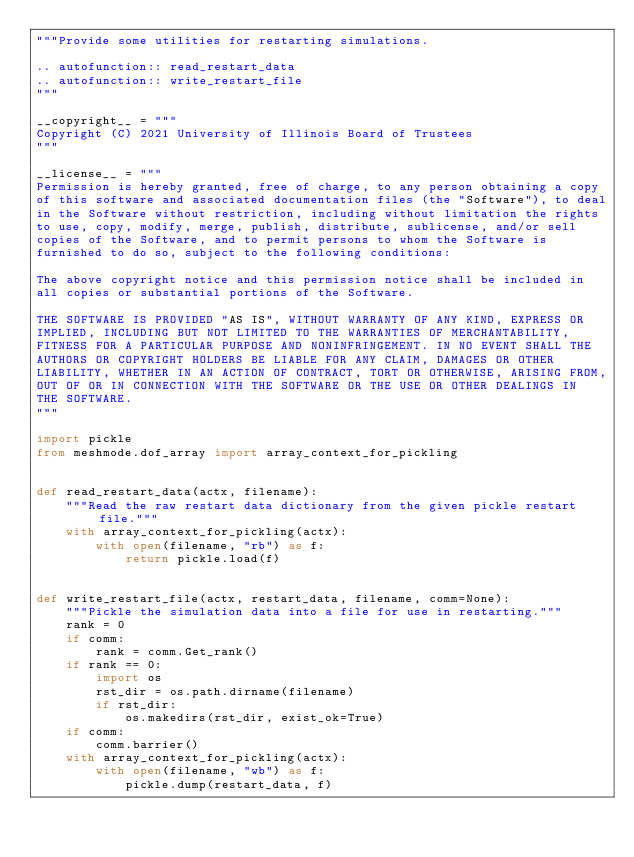<code> <loc_0><loc_0><loc_500><loc_500><_Python_>"""Provide some utilities for restarting simulations.

.. autofunction:: read_restart_data
.. autofunction:: write_restart_file
"""

__copyright__ = """
Copyright (C) 2021 University of Illinois Board of Trustees
"""

__license__ = """
Permission is hereby granted, free of charge, to any person obtaining a copy
of this software and associated documentation files (the "Software"), to deal
in the Software without restriction, including without limitation the rights
to use, copy, modify, merge, publish, distribute, sublicense, and/or sell
copies of the Software, and to permit persons to whom the Software is
furnished to do so, subject to the following conditions:

The above copyright notice and this permission notice shall be included in
all copies or substantial portions of the Software.

THE SOFTWARE IS PROVIDED "AS IS", WITHOUT WARRANTY OF ANY KIND, EXPRESS OR
IMPLIED, INCLUDING BUT NOT LIMITED TO THE WARRANTIES OF MERCHANTABILITY,
FITNESS FOR A PARTICULAR PURPOSE AND NONINFRINGEMENT. IN NO EVENT SHALL THE
AUTHORS OR COPYRIGHT HOLDERS BE LIABLE FOR ANY CLAIM, DAMAGES OR OTHER
LIABILITY, WHETHER IN AN ACTION OF CONTRACT, TORT OR OTHERWISE, ARISING FROM,
OUT OF OR IN CONNECTION WITH THE SOFTWARE OR THE USE OR OTHER DEALINGS IN
THE SOFTWARE.
"""

import pickle
from meshmode.dof_array import array_context_for_pickling


def read_restart_data(actx, filename):
    """Read the raw restart data dictionary from the given pickle restart file."""
    with array_context_for_pickling(actx):
        with open(filename, "rb") as f:
            return pickle.load(f)


def write_restart_file(actx, restart_data, filename, comm=None):
    """Pickle the simulation data into a file for use in restarting."""
    rank = 0
    if comm:
        rank = comm.Get_rank()
    if rank == 0:
        import os
        rst_dir = os.path.dirname(filename)
        if rst_dir:
            os.makedirs(rst_dir, exist_ok=True)
    if comm:
        comm.barrier()
    with array_context_for_pickling(actx):
        with open(filename, "wb") as f:
            pickle.dump(restart_data, f)
</code> 